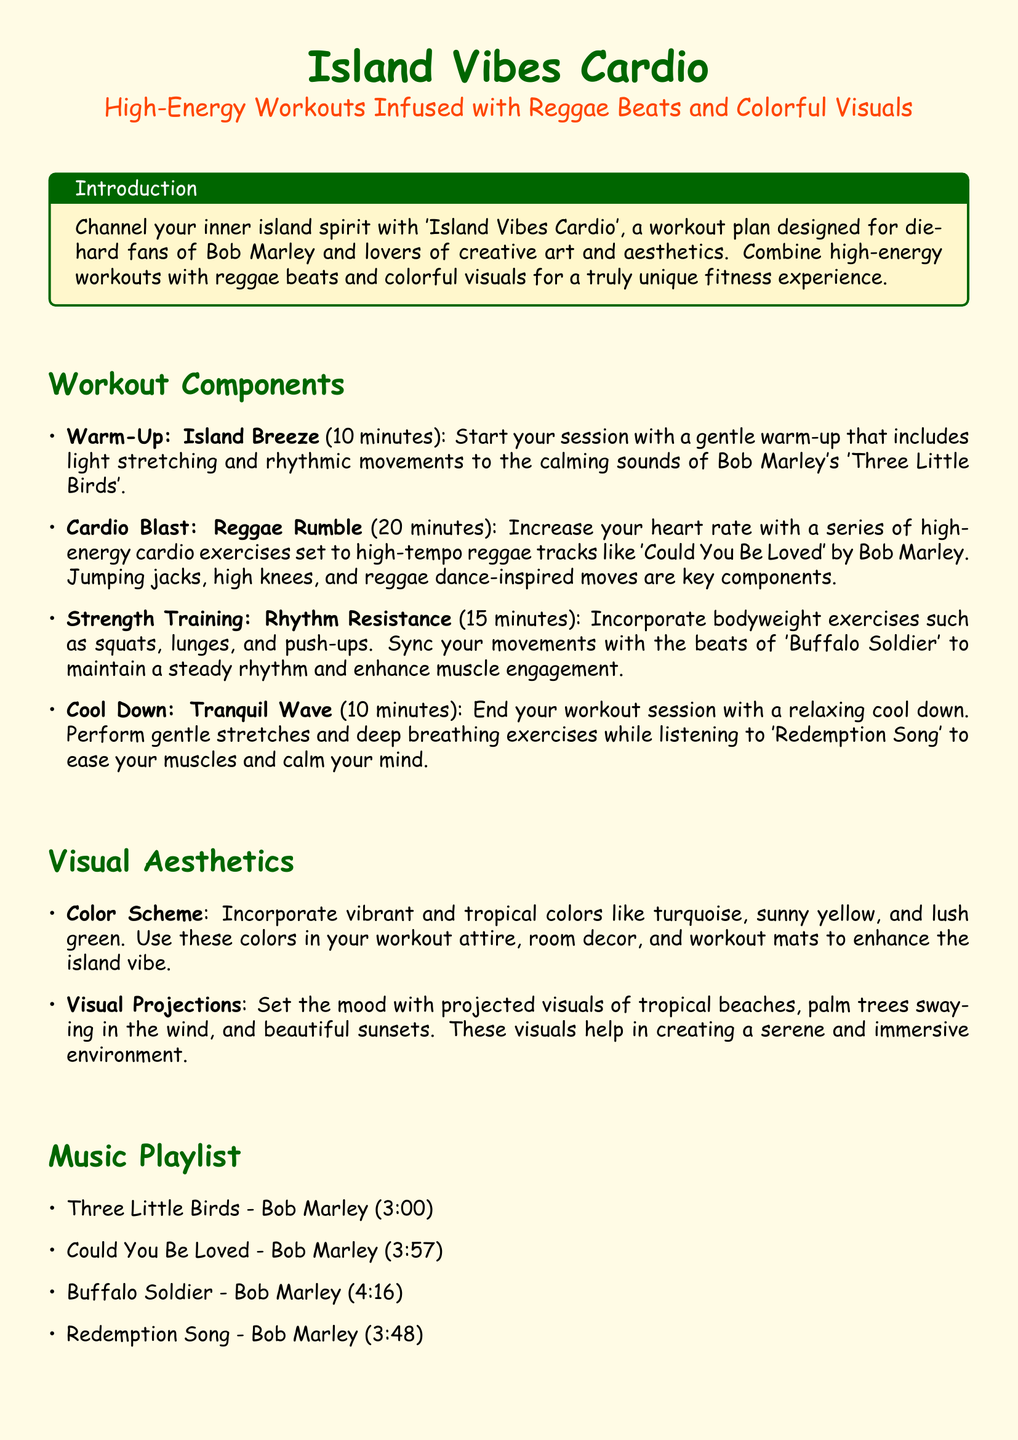What is the duration of the Warm-Up? The duration of the Warm-Up is specified in the workout plan, which is 10 minutes.
Answer: 10 minutes Which song is played during the Cool Down? The song played during the Cool Down is mentioned in the document, which is 'Redemption Song'.
Answer: Redemption Song What type of exercises are included in the Strength Training component? The document lists bodyweight exercises such as squats, lunges, and push-ups as part of the Strength Training.
Answer: Bodyweight exercises How long is the Cardio Blast segment? The duration of the Cardio Blast segment is given in the plan, which is 20 minutes.
Answer: 20 minutes What color scheme is recommended for the workout? The document suggests incorporating vibrant and tropical colors like turquoise, sunny yellow, and lush green for the workout.
Answer: Turquoise, sunny yellow, and lush green What is the main theme of the workout plan? The main theme is indicated in the introduction, focusing on the island spirit and reggae beats.
Answer: Island spirit and reggae beats Which Bob Marley song is 3 minutes long? The document lists the duration of songs, identifying 'Three Little Birds' as the song that is 3 minutes long.
Answer: Three Little Birds What should participants maintain throughout the workout? The document advises maintaining positivity and mindfulness throughout the workout.
Answer: Positivity and mindfulness 